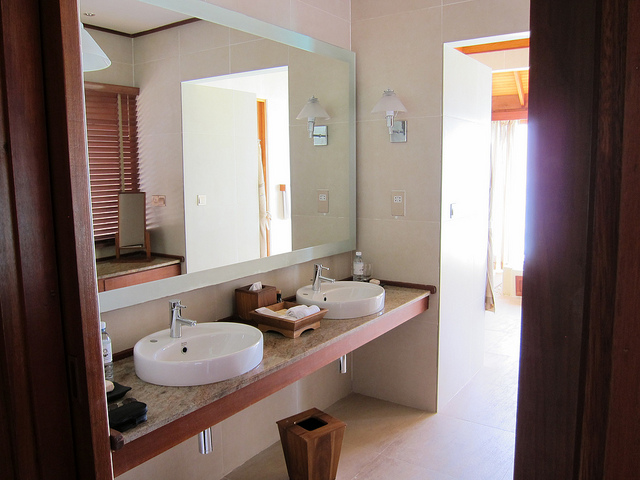What items or accessories are visible in the bathroom? Visible in the bathroom are two sinks, a large rectangular mirror that spans the length of the vanity, carefully placed soap dispensers, a small dustbin, and various other personal care items. These accessories are neatly arranged, promoting a sense of organized calm. 